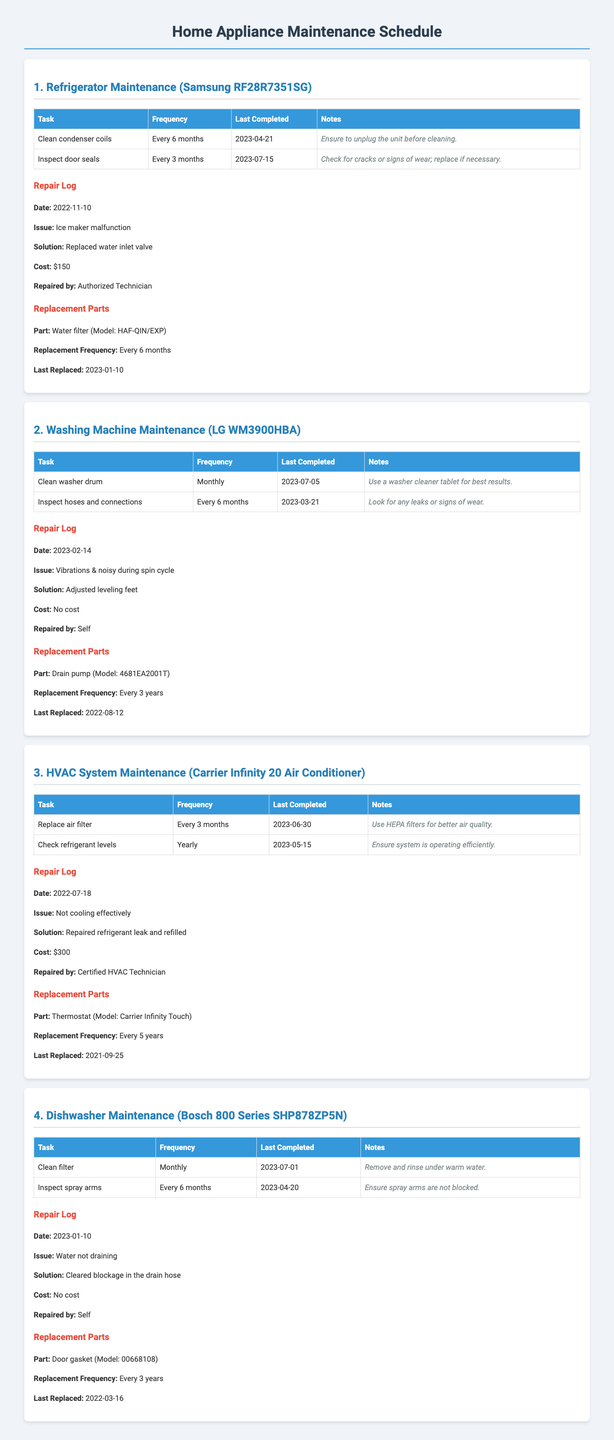What is the last completed maintenance for the refrigerator? The last maintenance task logged for the refrigerator was for inspecting door seals on July 15, 2023.
Answer: July 15, 2023 What was the cost of the ice maker repair for the refrigerator? The repair log indicates that the cost for replacing the water inlet valve was $150.
Answer: $150 What is the frequency for replacing the air filter in the HVAC system? In the maintenance schedule, the frequency for replacing the air filter is stated as every 3 months.
Answer: Every 3 months Who repaired the washing machine when it had vibrations? The repair log for the washing machine shows that it was repaired by the owner (self).
Answer: Self What is the last replaced date for the drain pump in the washing machine? According to the document, the drain pump was last replaced on August 12, 2022.
Answer: August 12, 2022 What issue did the dishwasher have in January 2023? The dishwasher repair log states that the issue was water not draining.
Answer: Water not draining What model is the thermostat used in the HVAC system? The replacement parts section identifies the thermostat model as Carrier Infinity Touch.
Answer: Carrier Infinity Touch What is the frequency for cleaning the washer drum? The document specifies that the washer drum should be cleaned monthly.
Answer: Monthly What was the solution for the dishwasher's blockage issue? The repair log indicates that the solution for the water not draining was clearing the blockage in the drain hose.
Answer: Cleared blockage in the drain hose 